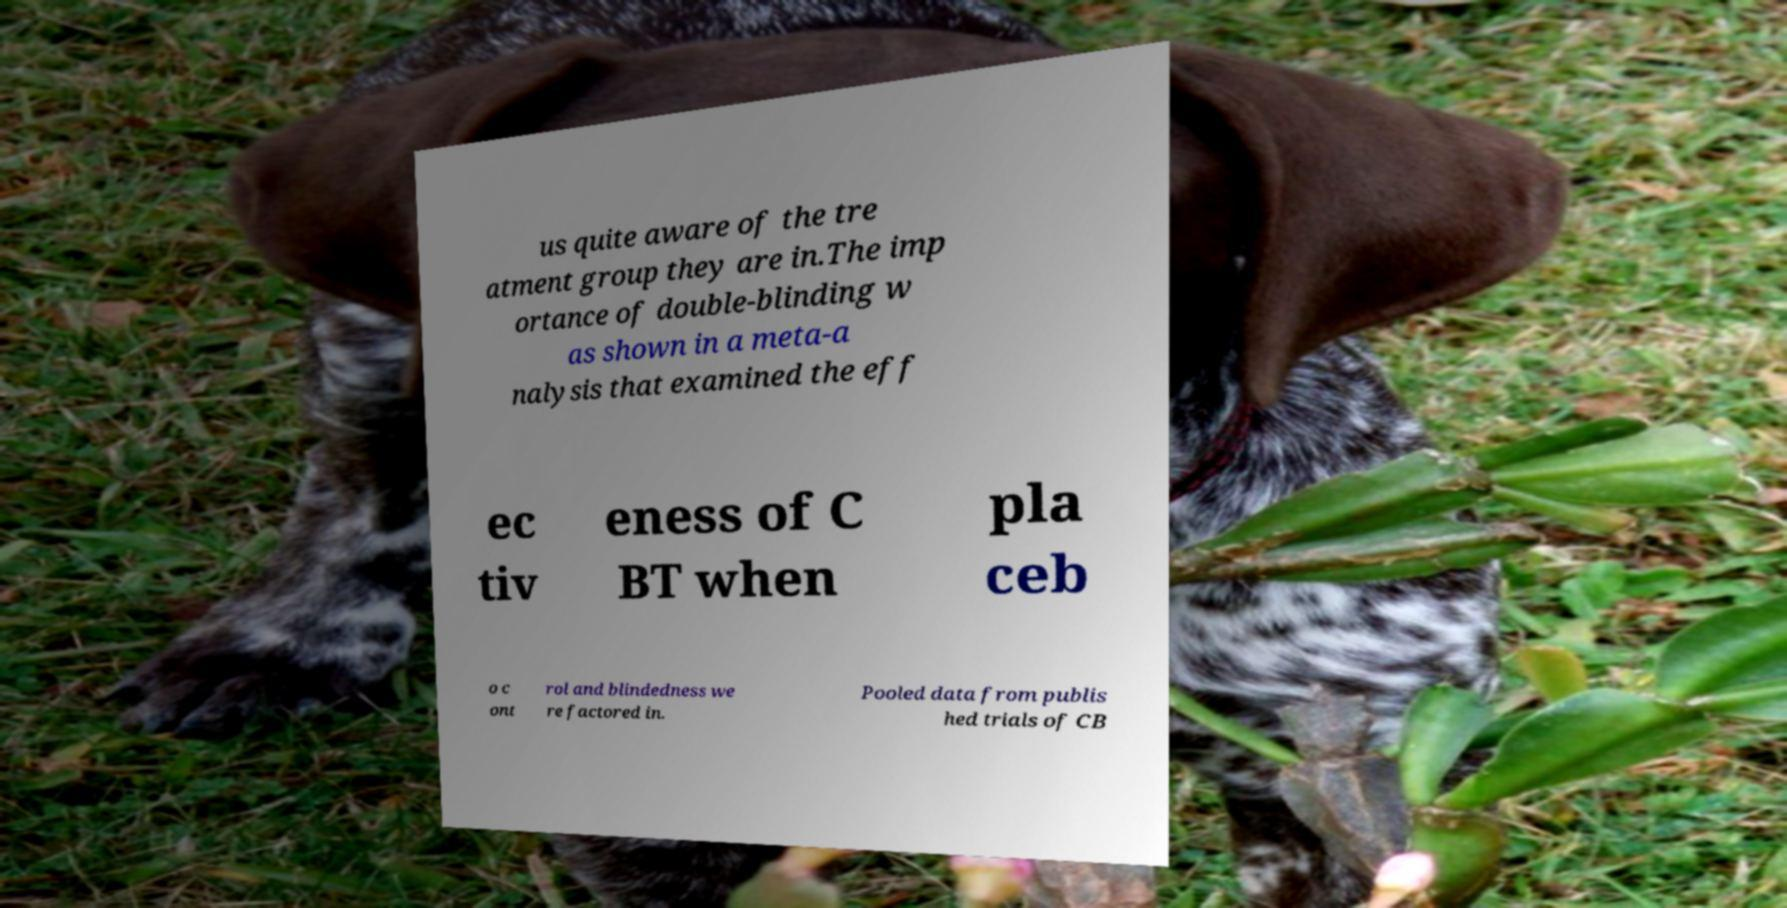Please identify and transcribe the text found in this image. us quite aware of the tre atment group they are in.The imp ortance of double-blinding w as shown in a meta-a nalysis that examined the eff ec tiv eness of C BT when pla ceb o c ont rol and blindedness we re factored in. Pooled data from publis hed trials of CB 